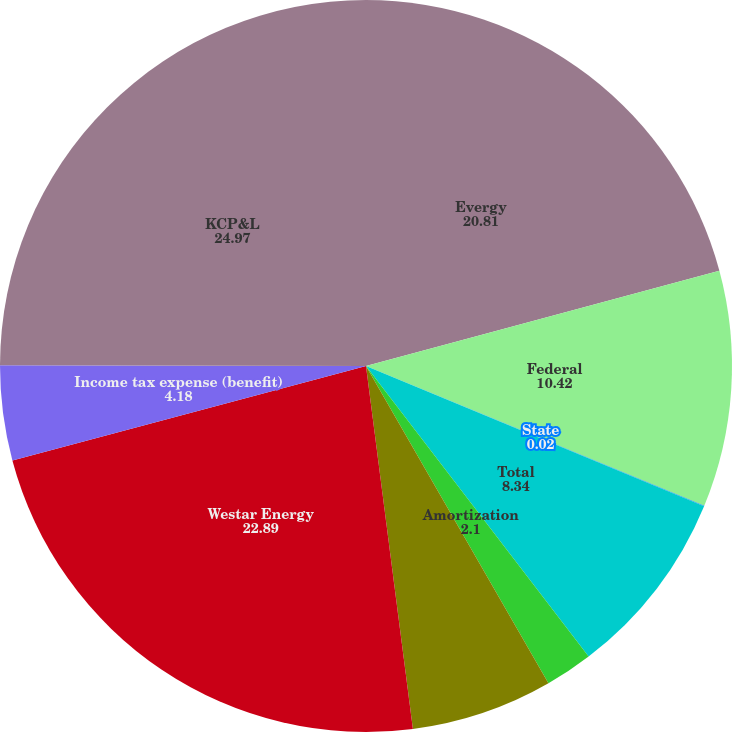Convert chart to OTSL. <chart><loc_0><loc_0><loc_500><loc_500><pie_chart><fcel>Evergy<fcel>Federal<fcel>State<fcel>Total<fcel>Amortization<fcel>Income tax expense<fcel>Westar Energy<fcel>Income tax expense (benefit)<fcel>KCP&L<nl><fcel>20.81%<fcel>10.42%<fcel>0.02%<fcel>8.34%<fcel>2.1%<fcel>6.26%<fcel>22.89%<fcel>4.18%<fcel>24.97%<nl></chart> 